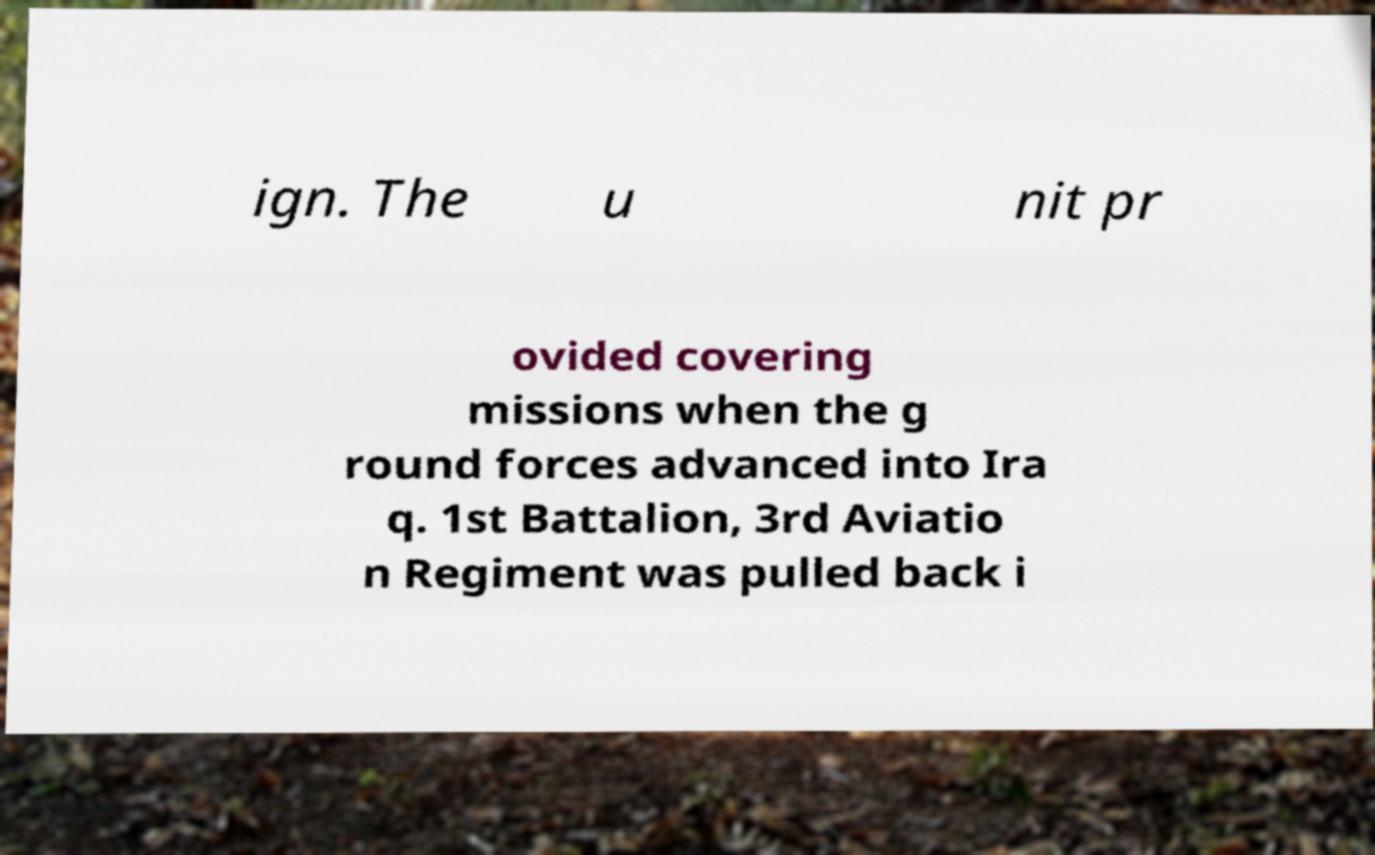Please read and relay the text visible in this image. What does it say? ign. The u nit pr ovided covering missions when the g round forces advanced into Ira q. 1st Battalion, 3rd Aviatio n Regiment was pulled back i 